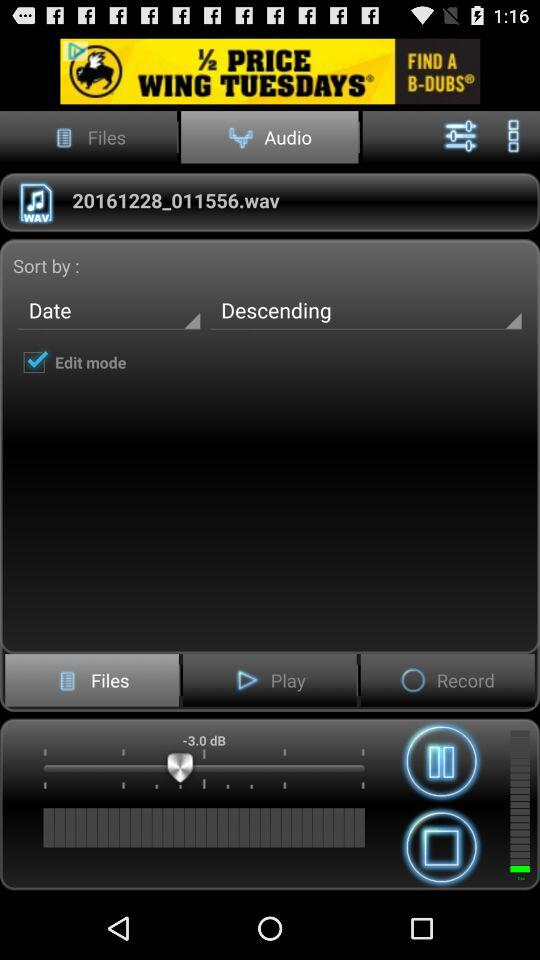Which tab is selected? The selected tab is "Audio". 